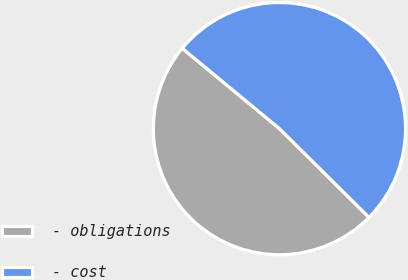<chart> <loc_0><loc_0><loc_500><loc_500><pie_chart><fcel>- obligations<fcel>- cost<nl><fcel>48.57%<fcel>51.43%<nl></chart> 